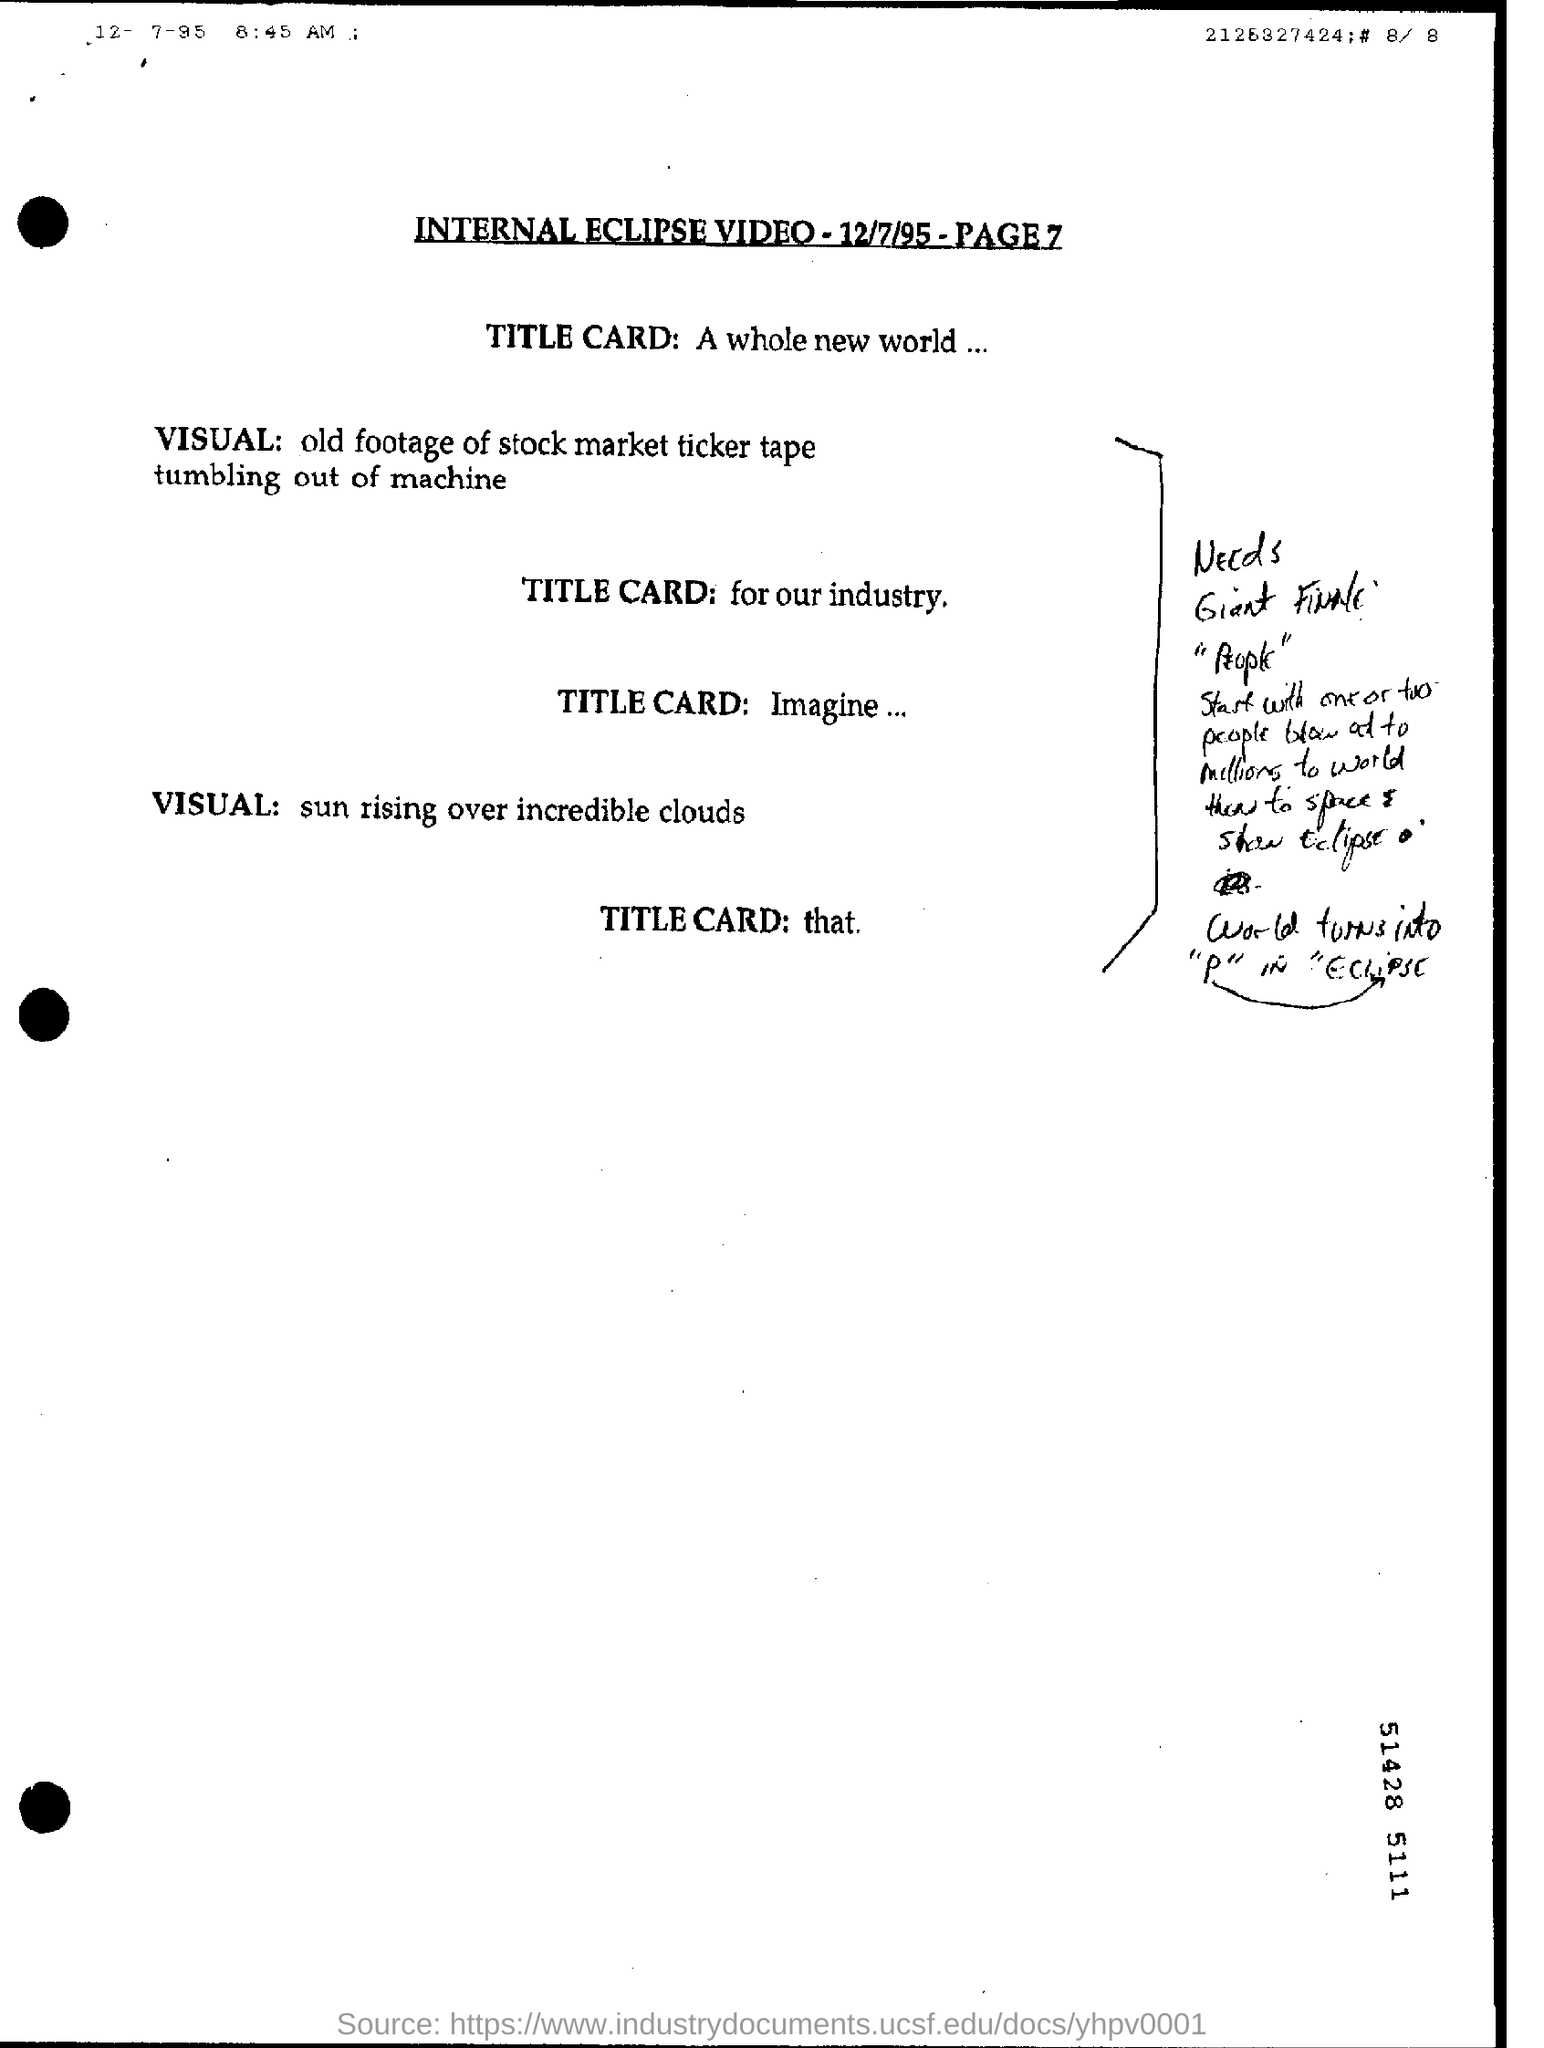Identify some key points in this picture. The word 'finally' turns into the letter 'P' in the script for the eclipse. The second VISUAL was of a beautiful sunrise over stunning clouds. A large number of people were killed in the incident, with some estimates suggesting that over a million may have been affected. The video was about internal eclipse. A significant number of people are able to achieve success by blowing out candles on their birthday cake, but the exact number is difficult to determine as it varies greatly depending on individual circumstances and goals. It is estimated that either one or two people out of millions are able to achieve this feat. 